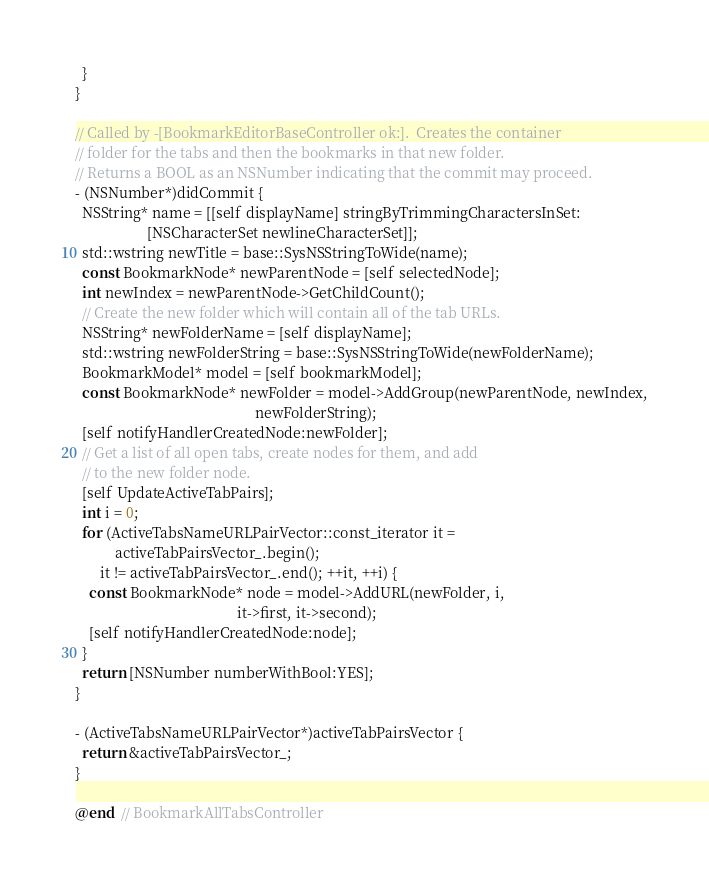Convert code to text. <code><loc_0><loc_0><loc_500><loc_500><_ObjectiveC_>  }
}

// Called by -[BookmarkEditorBaseController ok:].  Creates the container
// folder for the tabs and then the bookmarks in that new folder.
// Returns a BOOL as an NSNumber indicating that the commit may proceed.
- (NSNumber*)didCommit {
  NSString* name = [[self displayName] stringByTrimmingCharactersInSet:
                    [NSCharacterSet newlineCharacterSet]];
  std::wstring newTitle = base::SysNSStringToWide(name);
  const BookmarkNode* newParentNode = [self selectedNode];
  int newIndex = newParentNode->GetChildCount();
  // Create the new folder which will contain all of the tab URLs.
  NSString* newFolderName = [self displayName];
  std::wstring newFolderString = base::SysNSStringToWide(newFolderName);
  BookmarkModel* model = [self bookmarkModel];
  const BookmarkNode* newFolder = model->AddGroup(newParentNode, newIndex,
                                                  newFolderString);
  [self notifyHandlerCreatedNode:newFolder];
  // Get a list of all open tabs, create nodes for them, and add
  // to the new folder node.
  [self UpdateActiveTabPairs];
  int i = 0;
  for (ActiveTabsNameURLPairVector::const_iterator it =
           activeTabPairsVector_.begin();
       it != activeTabPairsVector_.end(); ++it, ++i) {
    const BookmarkNode* node = model->AddURL(newFolder, i,
                                             it->first, it->second);
    [self notifyHandlerCreatedNode:node];
  }
  return [NSNumber numberWithBool:YES];
}

- (ActiveTabsNameURLPairVector*)activeTabPairsVector {
  return &activeTabPairsVector_;
}

@end  // BookmarkAllTabsController

</code> 